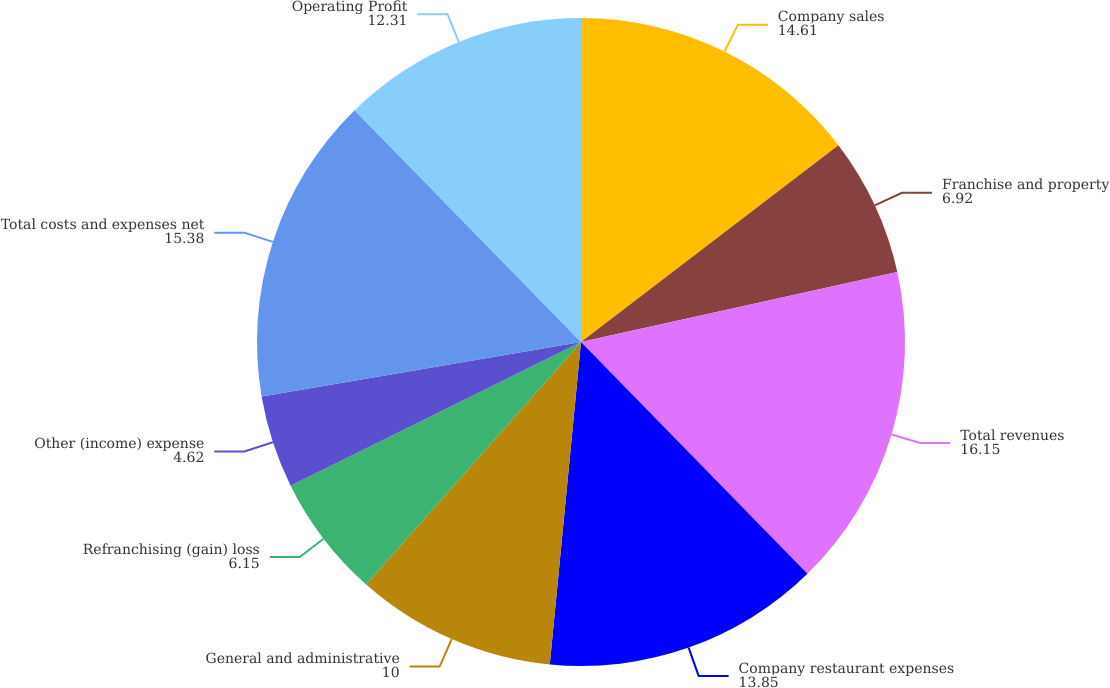<chart> <loc_0><loc_0><loc_500><loc_500><pie_chart><fcel>Company sales<fcel>Franchise and property<fcel>Total revenues<fcel>Company restaurant expenses<fcel>General and administrative<fcel>Refranchising (gain) loss<fcel>Other (income) expense<fcel>Total costs and expenses net<fcel>Operating Profit<nl><fcel>14.61%<fcel>6.92%<fcel>16.15%<fcel>13.85%<fcel>10.0%<fcel>6.15%<fcel>4.62%<fcel>15.38%<fcel>12.31%<nl></chart> 